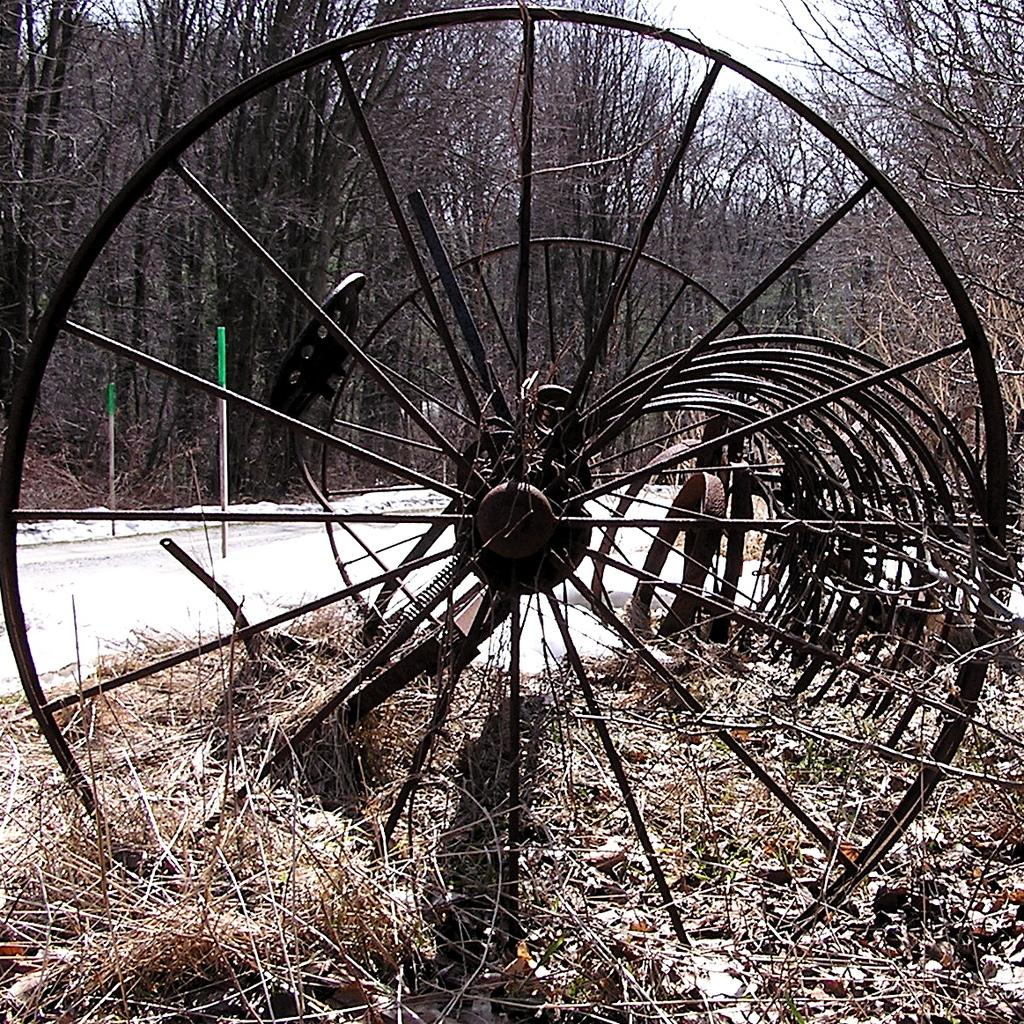What type of wheels can be seen on the grass in the image? Iron wheels are visible on the grass in the image. What can be found in the middle of the image? There are trees and a road in the middle of the image. What is visible at the top of the image? The sky is visible at the top of the image. When was the image taken? The image was taken during the day. How many cakes are displayed on the stone in the image? There are no cakes or stones present in the image. What type of view can be seen from the trees in the image? The image does not show a view from the trees, as it only displays the trees themselves. 